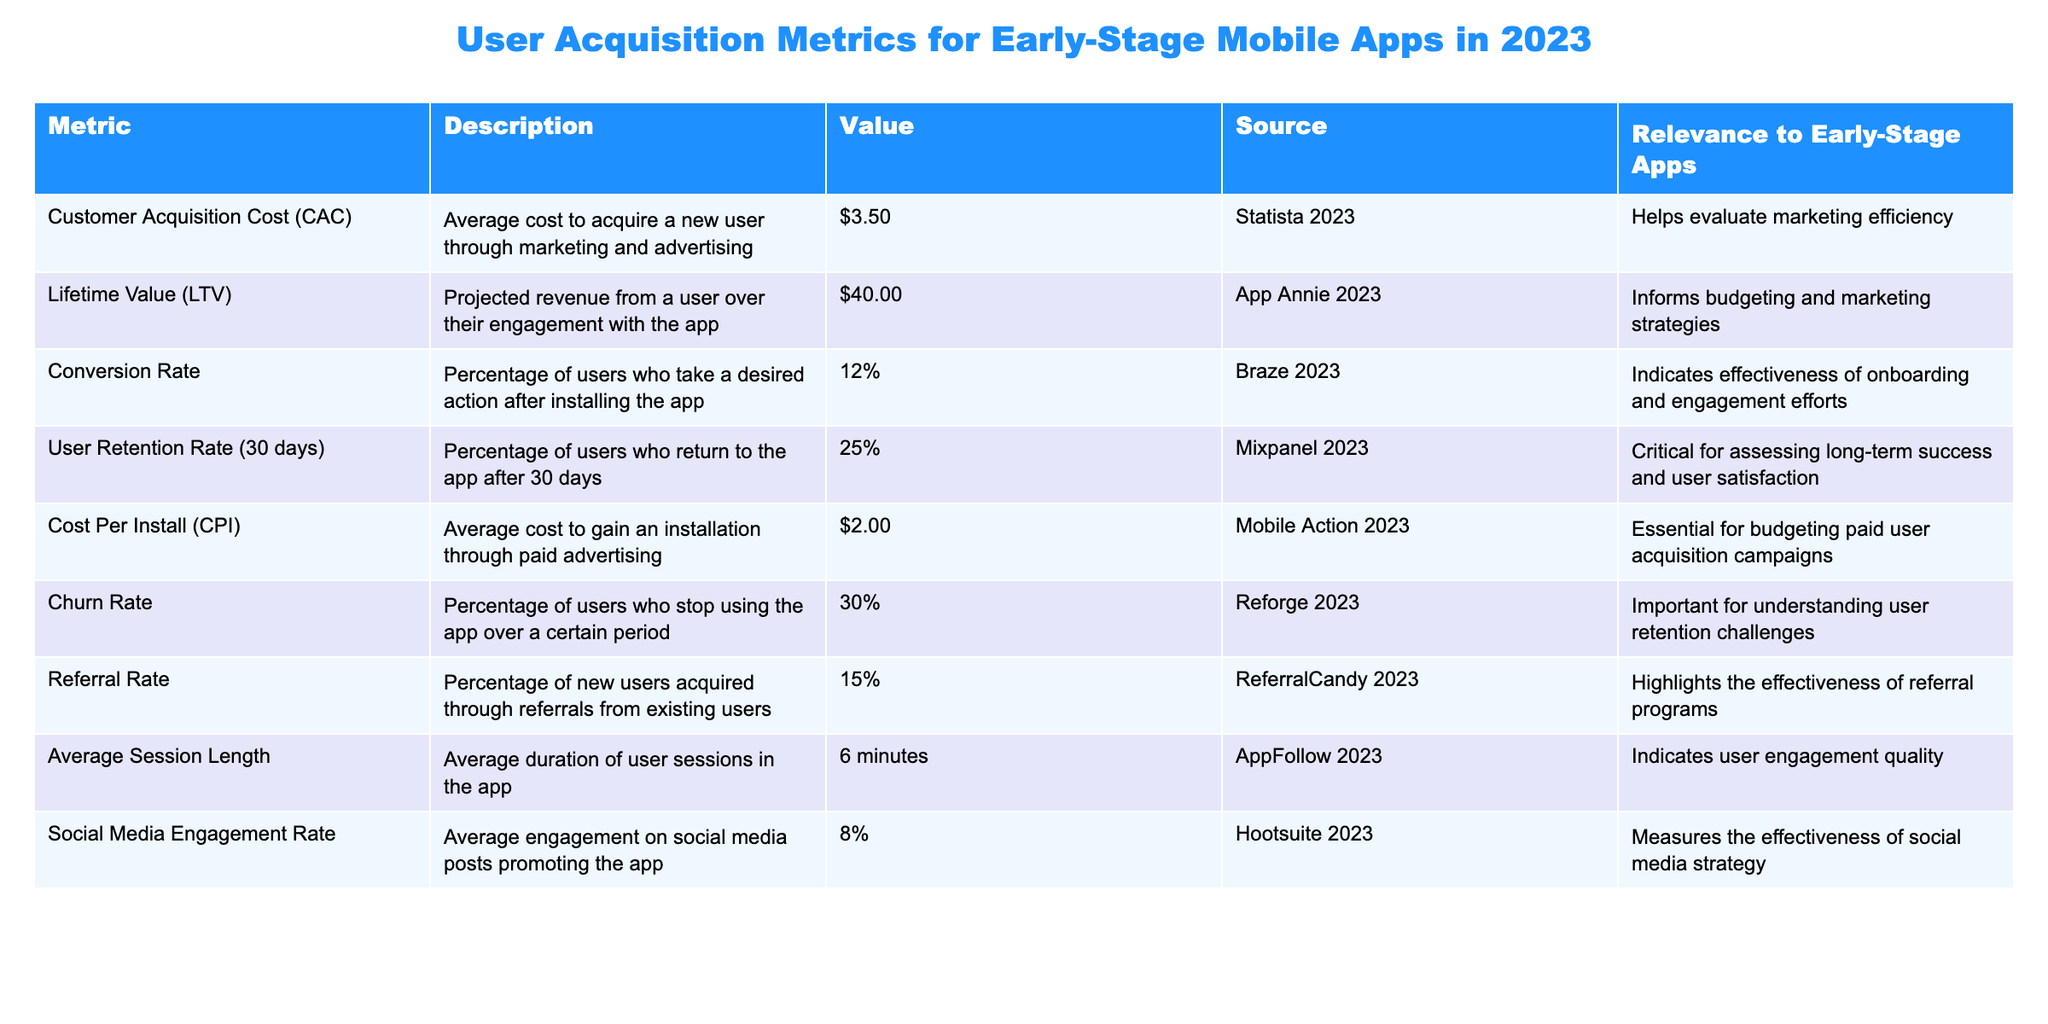What is the Customer Acquisition Cost (CAC) for early-stage mobile apps in 2023? The table lists the Customer Acquisition Cost (CAC) as $3.50. This is a specific retrieval request, where we only need to refer to the relevant row in the table.
Answer: $3.50 What is the Lifetime Value (LTV) for users of the app? According to the table, the Lifetime Value (LTV) is $40.00. This is a straightforward retrieval question where we reference the specific entry in the table.
Answer: $40.00 What is the average Conversion Rate for early-stage mobile apps? The Conversion Rate is listed as 12% in the table. This question involves a simple retrieval of the value from the table.
Answer: 12% How many users return to the app after 30 days? The User Retention Rate (30 days) is shown as 25%, indicating that 25% of users return to the app after 30 days. This is a direct reference to the value in the table.
Answer: 25% What is the Cost Per Install (CPI)? The table indicates that the Cost Per Install (CPI) is $2.00. This is a specific retrieval question that requires looking up one value from the table.
Answer: $2.00 What is the Churn Rate for early-stage mobile apps? The Churn Rate is reported as 30% in the table. This requires a simple retrieval of the information presented in the table.
Answer: 30% What percentage of new users come from referrals? The Referral Rate is provided in the table as 15%, meaning that 15% of new users are acquired through referrals. This is a simple retrieval of data from the table.
Answer: 15% What is the average session length in the app? The table shows the average session length is 6 minutes. This is a simple retrieval question based on the information provided.
Answer: 6 minutes Is the Social Media Engagement Rate above 10%? The Social Media Engagement Rate is listed as 8%. Since 8% is below 10%, the answer is no. This involves checking the value and comparing it to 10%.
Answer: No If the Customer Acquisition Cost is $3.50 and the Lifetime Value is $40.00, what is the ratio of LTV to CAC? The ratio of Lifetime Value (LTV) to Customer Acquisition Cost (CAC) can be calculated as LTV / CAC = $40.00 / $3.50. This equals approximately 11.43. This involves performing a division operation using the values from the table.
Answer: 11.43 What is the difference between Churn Rate and User Retention Rate (30 days)? Churn Rate is 30% and User Retention Rate is 25%. The difference is calculated as Churn Rate - User Retention Rate = 30% - 25% = 5%. This requires subtraction of two values.
Answer: 5% What are the implications of having a high Churn Rate in relation to the User Retention Rate? The Churn Rate of 30% indicates that a significant number of users stop using the app, while the User Retention Rate of 25% means only a quarter of users return after 30 days. Together, these suggest a retention challenge for the app. This analysis synthesizes information from both metrics for deeper understanding.
Answer: High churn signifies retention challenges Given the average CPI of $2.00 and the CAC of $3.50, is the user acquisition strategy efficient? To determine efficiency, compare CAC with CPI. Since CAC ($3.50) is higher than CPI ($2.00), it suggests inefficiency in the user acquisition strategy because it costs more to acquire a user than it does to gain an installation. This requires comparing two related metrics.
Answer: No, inefficient Considering the data, which metric would you prioritize to improve user engagement? Given the low User Retention Rate of 25% and average Session Length of 6 minutes, focusing on improving User Retention should be prioritized to enhance overall user engagement. This involves evaluating which metrics impact engagement more directly.
Answer: Prioritize User Retention 